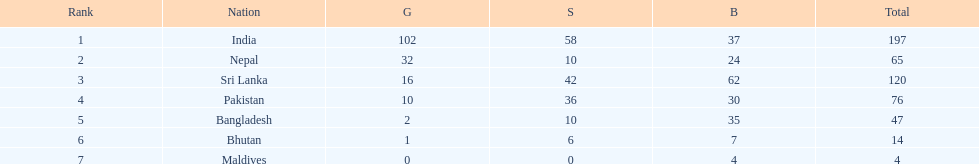Give me the full table as a dictionary. {'header': ['Rank', 'Nation', 'G', 'S', 'B', 'Total'], 'rows': [['1', 'India', '102', '58', '37', '197'], ['2', 'Nepal', '32', '10', '24', '65'], ['3', 'Sri Lanka', '16', '42', '62', '120'], ['4', 'Pakistan', '10', '36', '30', '76'], ['5', 'Bangladesh', '2', '10', '35', '47'], ['6', 'Bhutan', '1', '6', '7', '14'], ['7', 'Maldives', '0', '0', '4', '4']]} Which was the sole country to achieve under 10 medals in total? Maldives. 